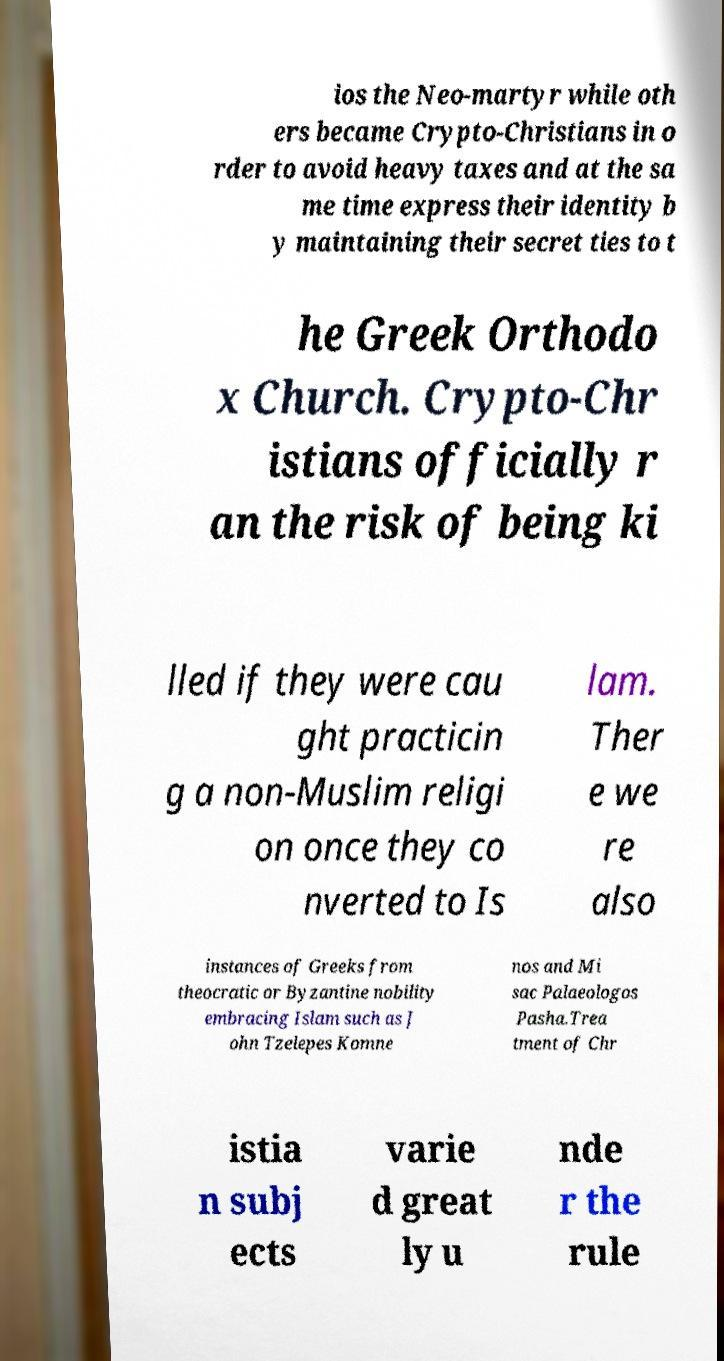There's text embedded in this image that I need extracted. Can you transcribe it verbatim? ios the Neo-martyr while oth ers became Crypto-Christians in o rder to avoid heavy taxes and at the sa me time express their identity b y maintaining their secret ties to t he Greek Orthodo x Church. Crypto-Chr istians officially r an the risk of being ki lled if they were cau ght practicin g a non-Muslim religi on once they co nverted to Is lam. Ther e we re also instances of Greeks from theocratic or Byzantine nobility embracing Islam such as J ohn Tzelepes Komne nos and Mi sac Palaeologos Pasha.Trea tment of Chr istia n subj ects varie d great ly u nde r the rule 